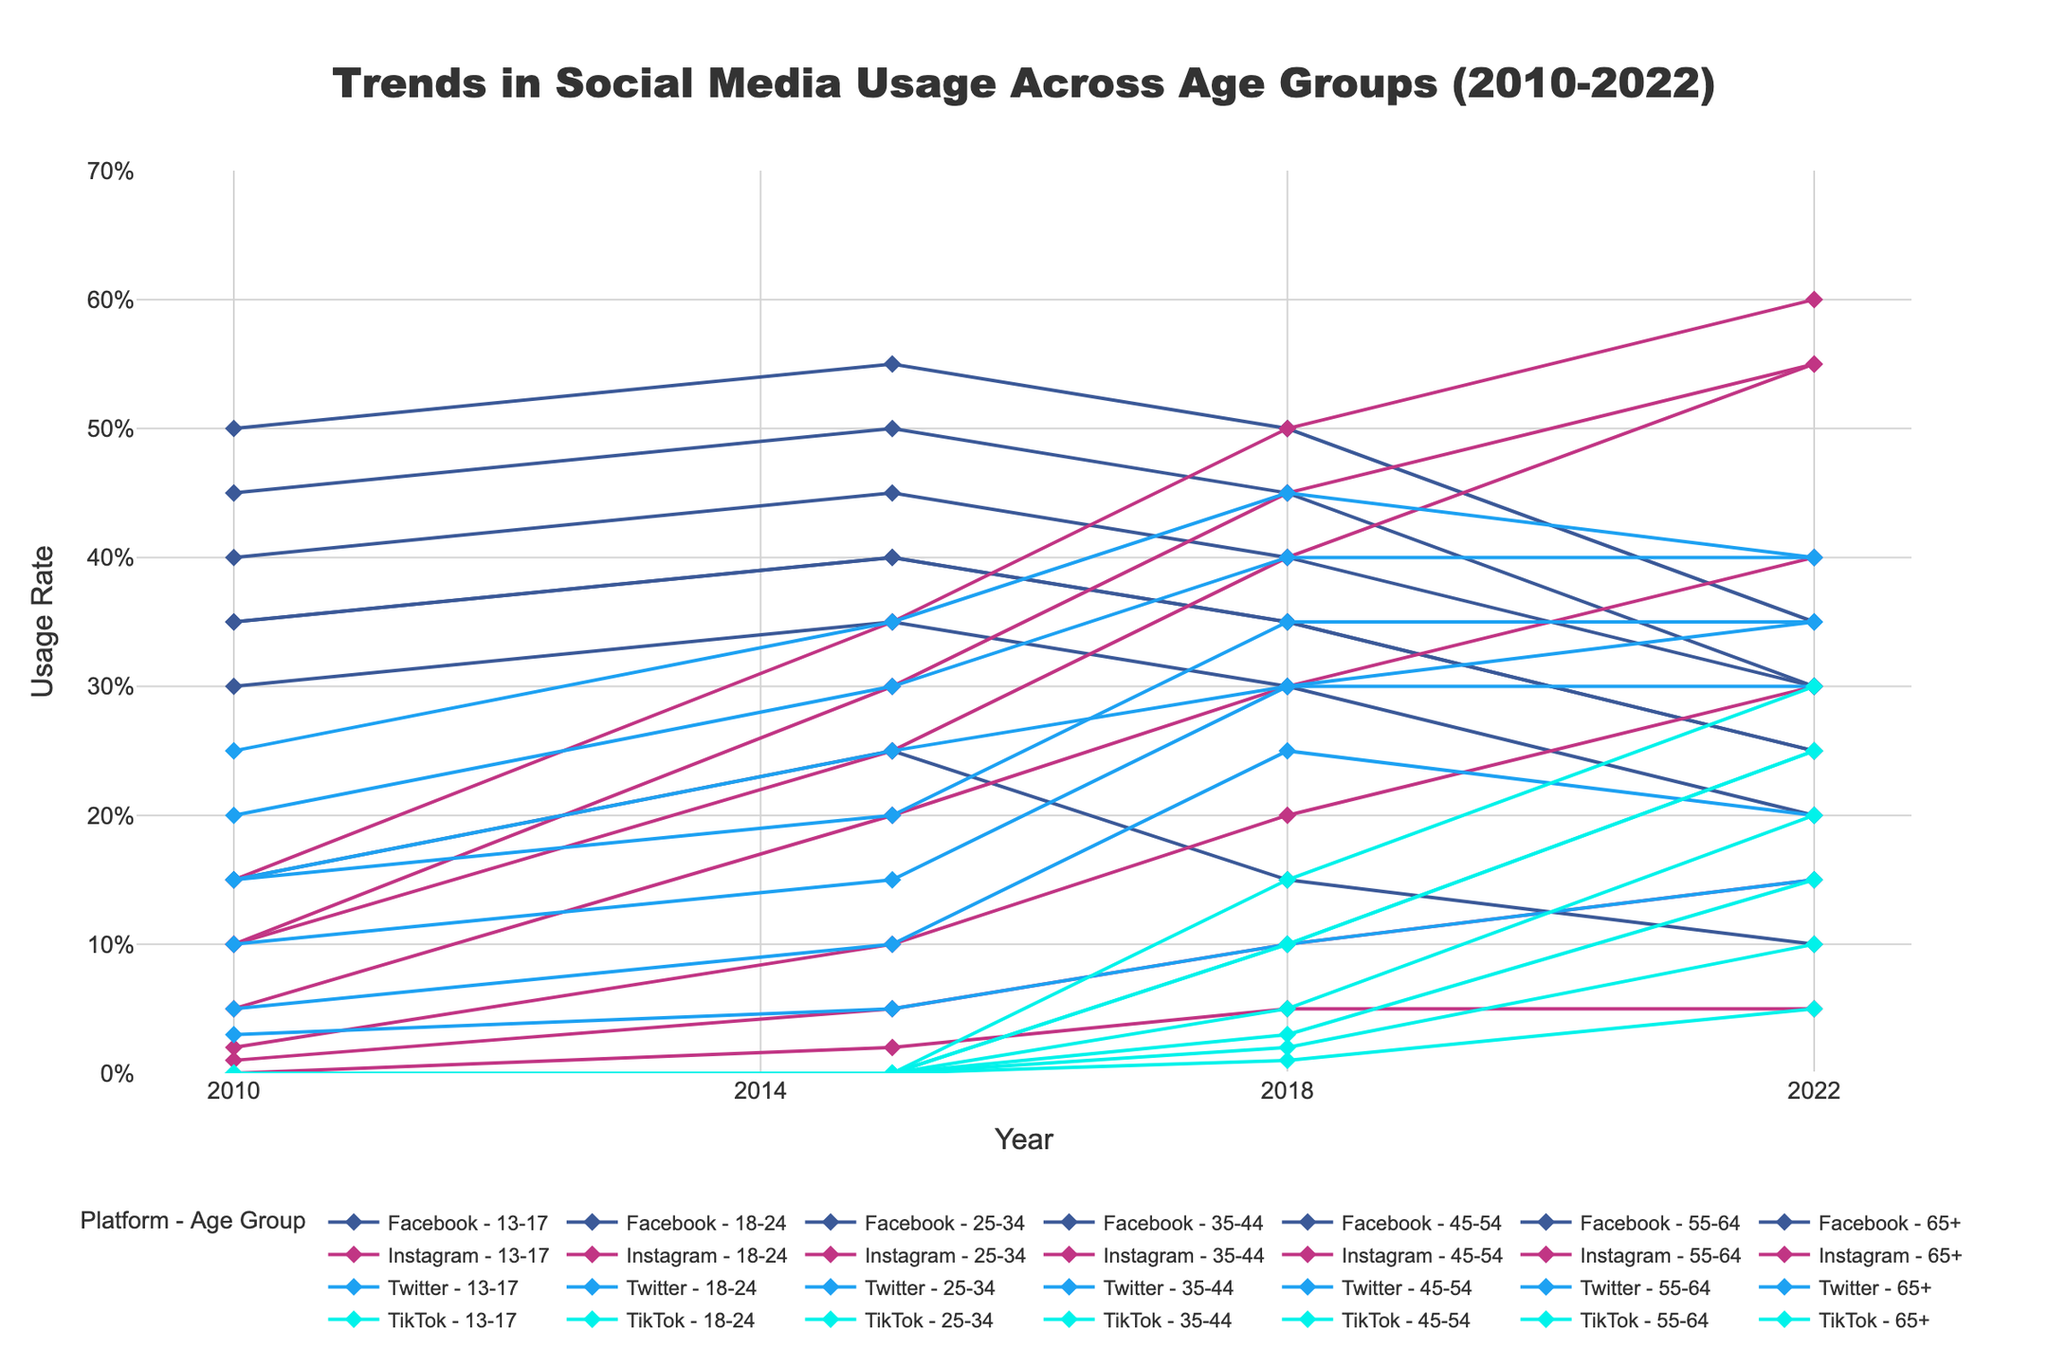What is the title of the figure? The title is located at the top of the figure and describes the main subject of the plot.
Answer: Trends in Social Media Usage Across Age Groups (2010-2022) Which platform had the highest usage among the 18-24 age group in 2022? Look at the 18-24 age group data points and identify which platform has the highest usage value for the year 2022.
Answer: Instagram How did the usage of TikTok evolve for the 13-17 age group from 2010 to 2022? Track the line or data points corresponding to TikTok for the 13-17 age group. Notice the trend and changes over the years.
Answer: Increased from 0% to 25% Compare the Instagram usage in 2018 between the 13-17 and 35-44 age groups. Which age group had higher usage? Identify the data points for Instagram usage in 2018 for both age groups and compare their values.
Answer: 13-17 age group What percentage difference in Facebook usage was seen between the 25-34 and 65+ age groups in 2010? Find the Facebook usage for both age groups in 2010, subtract the smaller percentage from the larger one, and express the difference in percentage points.
Answer: 35% Which social media platform showed an increase in usage for all age groups from 2010 to 2022? Analyze the trends across all age groups for each platform and identify which one consistently increased.
Answer: Instagram How did the usage trend of Facebook change for the 55-64 age group from 2010 to 2022? Track the Facebook data points for the 55-64 age group over the years and observe the changes.
Answer: Decreased from 30% to 20% What was the average Twitter usage of the 18-24 age group over the years provided? Find the Twitter usage values for the 18-24 age group for all given years and calculate the average. (0.20 + 0.30 + 0.40 + 0.40) / 4
Answer: 32.5% Which age group had the lowest Instagram usage in 2022, and what was the value? Look at the Instagram usage data points for the year 2022 and identify the age group with the lowest value.
Answer: 65+, 5% Compare the Facebook usage trend for the 35-44 and 45-54 age groups from 2010 to 2022. Which age group showed a greater decline? Analyze the Facebook usage data points for both age groups over the years and calculate the decline for each group.
Answer: 35-44 age group 